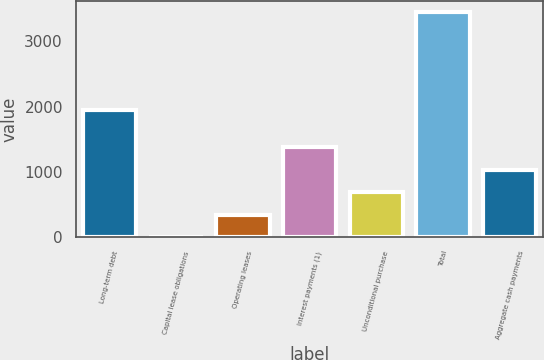<chart> <loc_0><loc_0><loc_500><loc_500><bar_chart><fcel>Long-term debt<fcel>Capital lease obligations<fcel>Operating leases<fcel>Interest payments (1)<fcel>Unconditional purchase<fcel>Total<fcel>Aggregate cash payments<nl><fcel>1951<fcel>2<fcel>346.6<fcel>1380.4<fcel>691.2<fcel>3448<fcel>1035.8<nl></chart> 